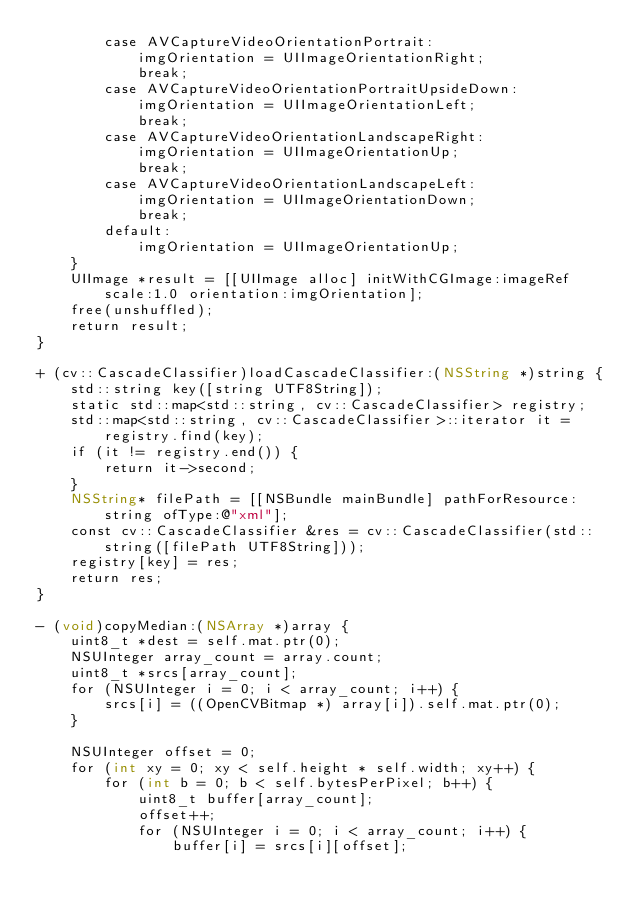<code> <loc_0><loc_0><loc_500><loc_500><_ObjectiveC_>        case AVCaptureVideoOrientationPortrait:
            imgOrientation = UIImageOrientationRight;
            break;
        case AVCaptureVideoOrientationPortraitUpsideDown:
            imgOrientation = UIImageOrientationLeft;
            break;
        case AVCaptureVideoOrientationLandscapeRight:
            imgOrientation = UIImageOrientationUp;
            break;
        case AVCaptureVideoOrientationLandscapeLeft:
            imgOrientation = UIImageOrientationDown;
            break;
        default:
            imgOrientation = UIImageOrientationUp;
    }
    UIImage *result = [[UIImage alloc] initWithCGImage:imageRef scale:1.0 orientation:imgOrientation];
    free(unshuffled);
    return result;
}

+ (cv::CascadeClassifier)loadCascadeClassifier:(NSString *)string {
    std::string key([string UTF8String]);
    static std::map<std::string, cv::CascadeClassifier> registry;
    std::map<std::string, cv::CascadeClassifier>::iterator it = registry.find(key);
    if (it != registry.end()) {
        return it->second;
    }
    NSString* filePath = [[NSBundle mainBundle] pathForResource:string ofType:@"xml"];
    const cv::CascadeClassifier &res = cv::CascadeClassifier(std::string([filePath UTF8String]));
    registry[key] = res;
    return res;
}

- (void)copyMedian:(NSArray *)array {
    uint8_t *dest = self.mat.ptr(0);
    NSUInteger array_count = array.count;
    uint8_t *srcs[array_count];
    for (NSUInteger i = 0; i < array_count; i++) {
        srcs[i] = ((OpenCVBitmap *) array[i]).self.mat.ptr(0);
    }

    NSUInteger offset = 0;
    for (int xy = 0; xy < self.height * self.width; xy++) {
        for (int b = 0; b < self.bytesPerPixel; b++) {
            uint8_t buffer[array_count];
            offset++;
            for (NSUInteger i = 0; i < array_count; i++) {
                buffer[i] = srcs[i][offset];</code> 